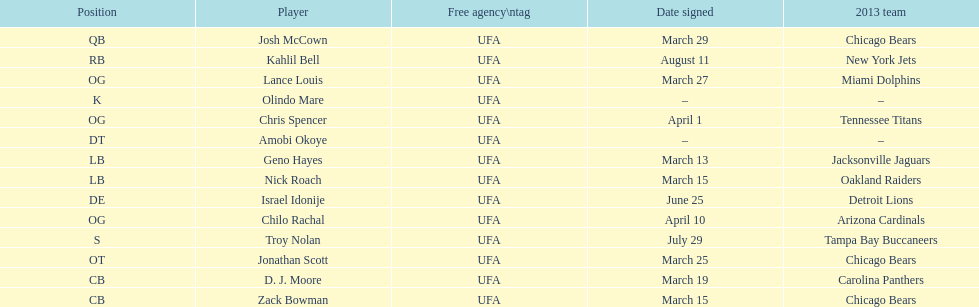Who was the previous player signed before troy nolan? Israel Idonije. 